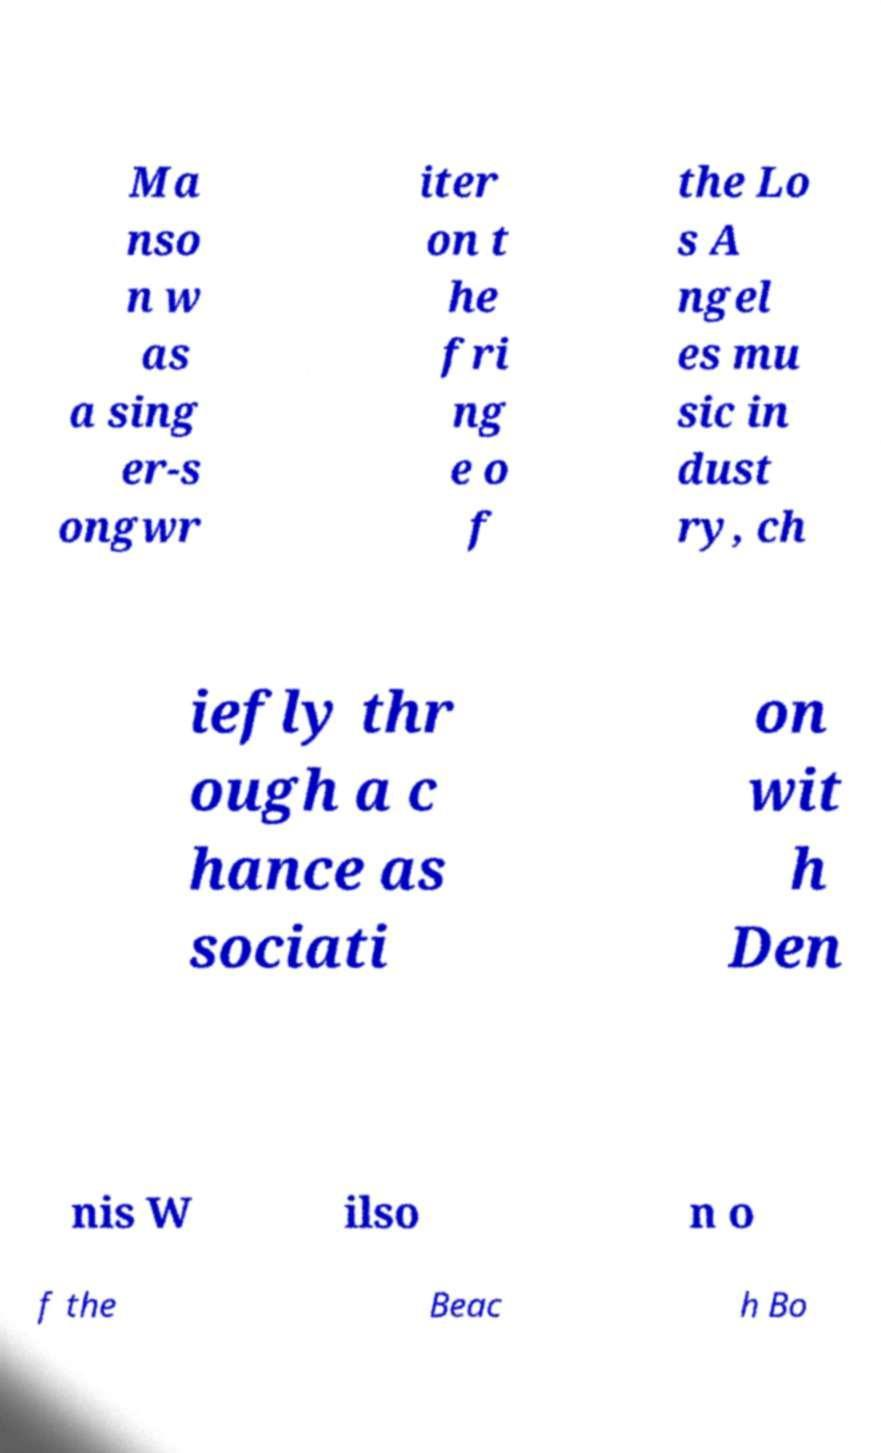For documentation purposes, I need the text within this image transcribed. Could you provide that? Ma nso n w as a sing er-s ongwr iter on t he fri ng e o f the Lo s A ngel es mu sic in dust ry, ch iefly thr ough a c hance as sociati on wit h Den nis W ilso n o f the Beac h Bo 